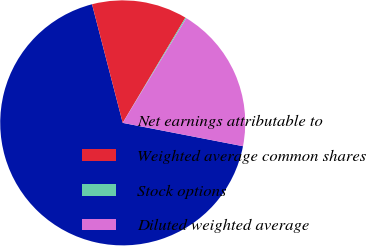<chart> <loc_0><loc_0><loc_500><loc_500><pie_chart><fcel>Net earnings attributable to<fcel>Weighted average common shares<fcel>Stock options<fcel>Diluted weighted average<nl><fcel>67.92%<fcel>12.58%<fcel>0.14%<fcel>19.36%<nl></chart> 